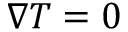Convert formula to latex. <formula><loc_0><loc_0><loc_500><loc_500>\nabla T = 0</formula> 